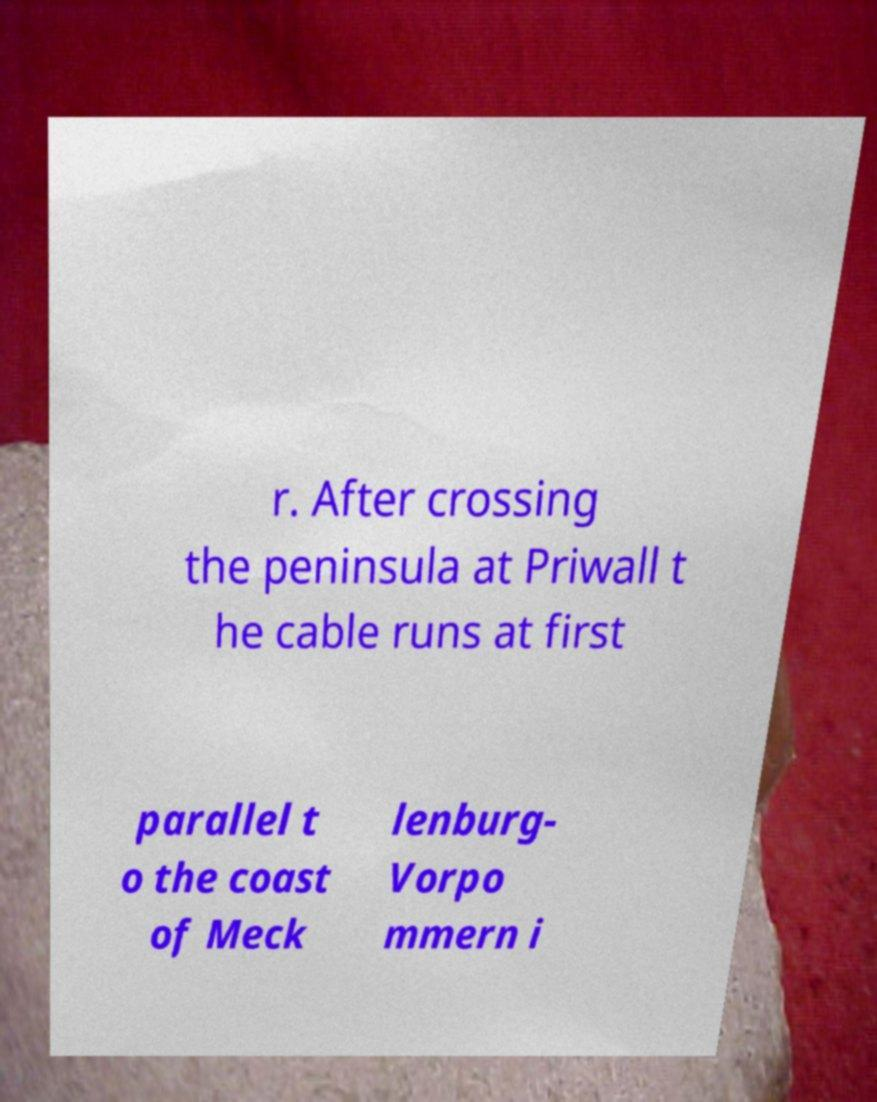Please read and relay the text visible in this image. What does it say? r. After crossing the peninsula at Priwall t he cable runs at first parallel t o the coast of Meck lenburg- Vorpo mmern i 